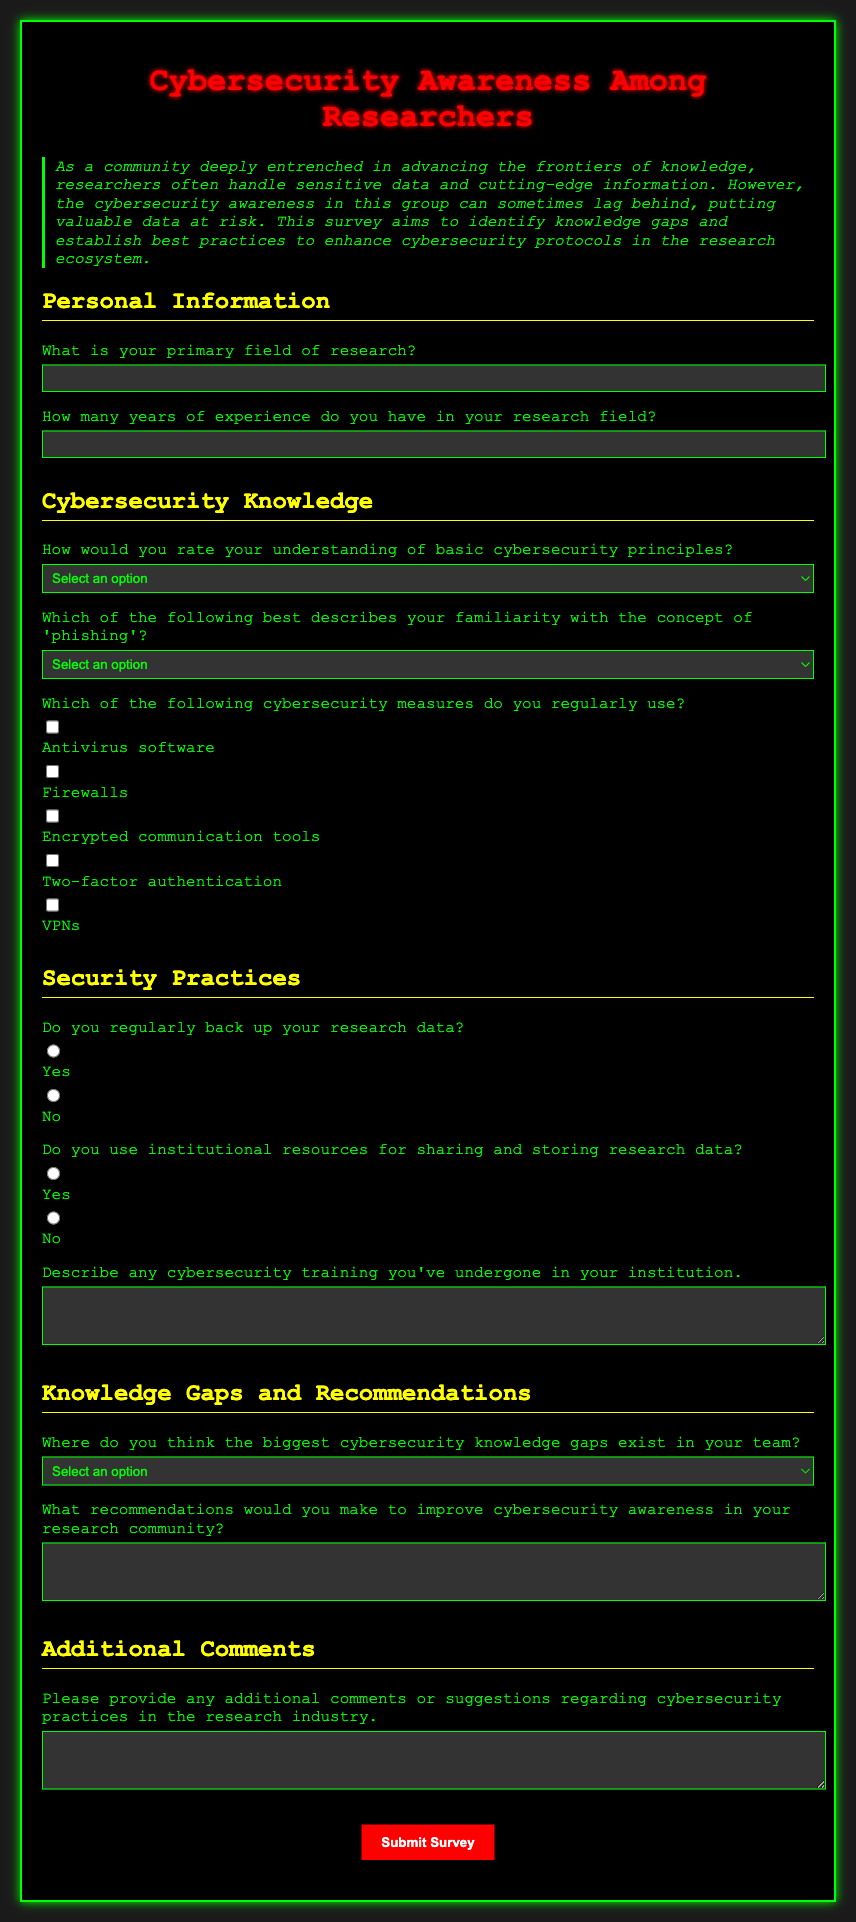What is the title of the survey? The title of the survey is clearly stated at the top of the document.
Answer: Cybersecurity Awareness Among Researchers What color is the background of the form? The background color of the form is specified in the style section of the document.
Answer: #1a1a1a What is the required experience input format? The required input for experience is in a text field, as indicated in the document.
Answer: Text How many years of experience does the survey ask about? The survey specifically asks for the number of years of experience in the research field.
Answer: Number What type of question is used to assess familiarity with phishing? The document describes the type of question used for phishing familiarity.
Answer: Multiple choice What is one of the security measures that can be checked? The document lists various cybersecurity measures that can be selected in checkboxes.
Answer: Antivirus software What type of data does the survey ask about backing up? The survey asks about backing up different types of research-related data.
Answer: Research data What is a potential knowledge gap identified in the survey? The survey provides a list of options regarding knowledge gaps where respondents can identify issues.
Answer: Phishing awareness What is asked for in the recommendations section? The document specifies what type of input is required in the recommendations section.
Answer: Suggestions to improve cybersecurity awareness 